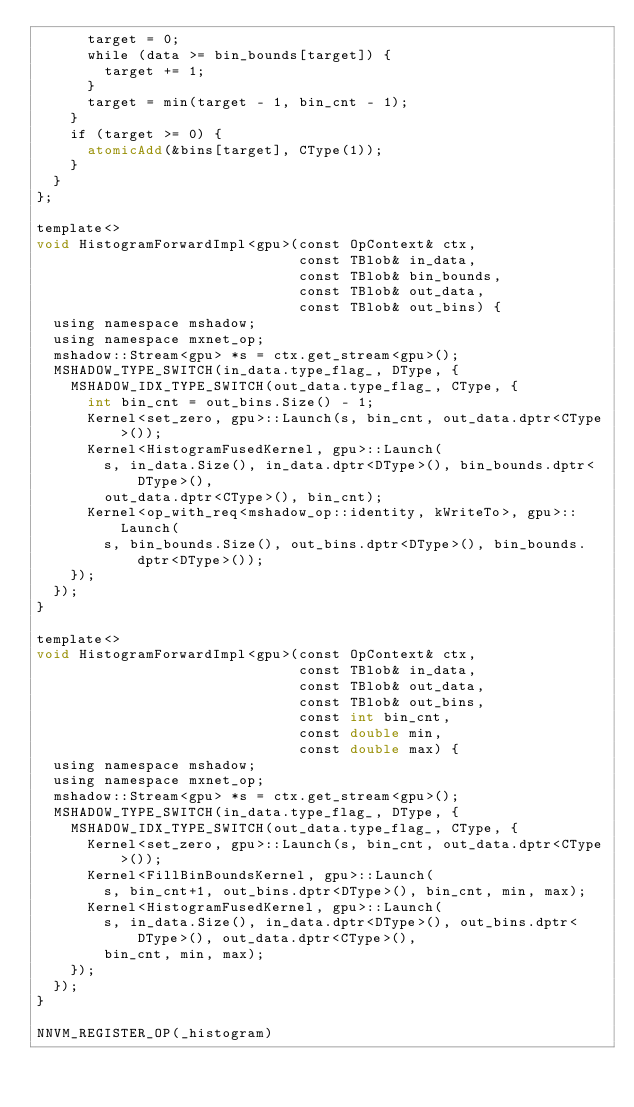Convert code to text. <code><loc_0><loc_0><loc_500><loc_500><_Cuda_>      target = 0;
      while (data >= bin_bounds[target]) {
        target += 1;
      }
      target = min(target - 1, bin_cnt - 1);
    }
    if (target >= 0) {
      atomicAdd(&bins[target], CType(1));
    }
  }
};

template<>
void HistogramForwardImpl<gpu>(const OpContext& ctx,
                               const TBlob& in_data,
                               const TBlob& bin_bounds,
                               const TBlob& out_data,
                               const TBlob& out_bins) {
  using namespace mshadow;
  using namespace mxnet_op;
  mshadow::Stream<gpu> *s = ctx.get_stream<gpu>();
  MSHADOW_TYPE_SWITCH(in_data.type_flag_, DType, {
    MSHADOW_IDX_TYPE_SWITCH(out_data.type_flag_, CType, {
      int bin_cnt = out_bins.Size() - 1;
      Kernel<set_zero, gpu>::Launch(s, bin_cnt, out_data.dptr<CType>());
      Kernel<HistogramFusedKernel, gpu>::Launch(
        s, in_data.Size(), in_data.dptr<DType>(), bin_bounds.dptr<DType>(),
        out_data.dptr<CType>(), bin_cnt);
      Kernel<op_with_req<mshadow_op::identity, kWriteTo>, gpu>::Launch(
        s, bin_bounds.Size(), out_bins.dptr<DType>(), bin_bounds.dptr<DType>());
    });
  });
}

template<>
void HistogramForwardImpl<gpu>(const OpContext& ctx,
                               const TBlob& in_data,
                               const TBlob& out_data,
                               const TBlob& out_bins,
                               const int bin_cnt,
                               const double min,
                               const double max) {
  using namespace mshadow;
  using namespace mxnet_op;
  mshadow::Stream<gpu> *s = ctx.get_stream<gpu>();
  MSHADOW_TYPE_SWITCH(in_data.type_flag_, DType, {
    MSHADOW_IDX_TYPE_SWITCH(out_data.type_flag_, CType, {
      Kernel<set_zero, gpu>::Launch(s, bin_cnt, out_data.dptr<CType>());
      Kernel<FillBinBoundsKernel, gpu>::Launch(
        s, bin_cnt+1, out_bins.dptr<DType>(), bin_cnt, min, max);
      Kernel<HistogramFusedKernel, gpu>::Launch(
        s, in_data.Size(), in_data.dptr<DType>(), out_bins.dptr<DType>(), out_data.dptr<CType>(),
        bin_cnt, min, max);
    });
  });
}

NNVM_REGISTER_OP(_histogram)</code> 